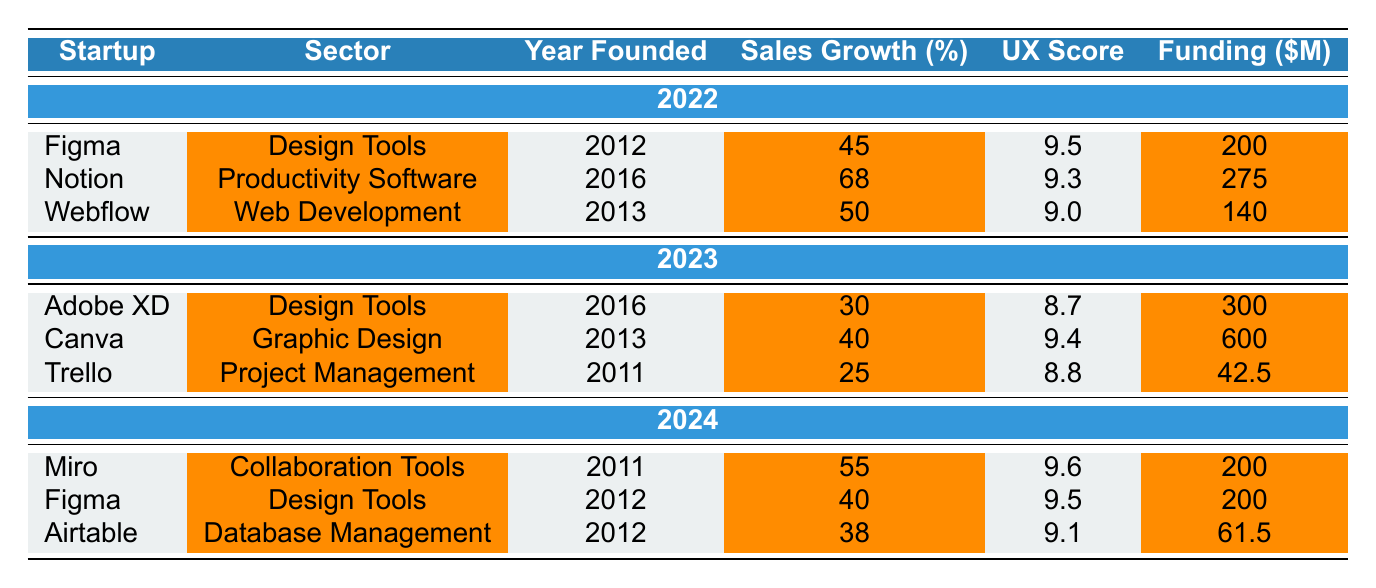What was the Sales Growth Percentage of Notion in 2022? The table shows that Notion had a Sales Growth Percentage of 68% in 2022.
Answer: 68% Which startup had the highest User Experience Score in 2024? Miro had the highest User Experience Score of 9.6 in 2024 according to the table.
Answer: Miro What is the average Sales Growth Percentage for all startups listed in 2023? The Sales Growth Percentages for the startups in 2023 are 30%, 40%, and 25%. The average is (30 + 40 + 25) / 3 = 95 / 3 = 31.67%.
Answer: 31.67% Did Adobe XD have a higher User Experience Score than Trello in 2023? Adobe XD had a User Experience Score of 8.7 while Trello had a score of 8.8. Since 8.7 is less than 8.8, the answer is no.
Answer: No Which sector did Figma belong to in 2022, and how much funding did it raise in that year? Figma belonged to the Design Tools sector and raised $200 million in 2022, as shown in the table.
Answer: Design Tools, $200 million What was the total Sales Growth Percentage of startups from 2024? The Sales Growth Percentages for 2024 are 55%, 40%, and 38%. The total is 55 + 40 + 38 = 133%.
Answer: 133% Which startup had the lowest Sales Growth Percentage and what was the percentage? Trello had the lowest Sales Growth Percentage of 25% in 2023 as per the table.
Answer: Trello, 25% Is there any startup listed in 2022 that was not present in 2023? Figma and Webflow are present in 2022 but not in 2023, as their names do not appear under 2023 startups.
Answer: Yes What is the sum of the funding raised by all startups in 2022? The total funding raised by all startups in 2022 is $200 million (Figma) + $275 million (Notion) + $140 million (Webflow) = $615 million.
Answer: $615 million Which startup experienced a decline in sales growth from 2022 to 2023? Trello had a Sales Growth Percentage of 25% in 2023, while there are no other comparisons needed because 2022 is distinct from 2023, hence, it is the only startup noted for a drop since the others belong to another year.
Answer: Trello 